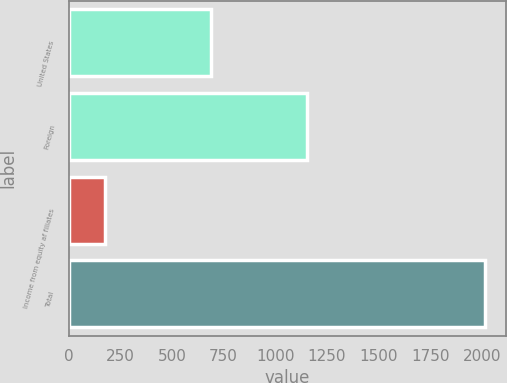<chart> <loc_0><loc_0><loc_500><loc_500><bar_chart><fcel>United States<fcel>Foreign<fcel>Income from equity af filiates<fcel>Total<nl><fcel>688.5<fcel>1151.7<fcel>174.8<fcel>2015<nl></chart> 